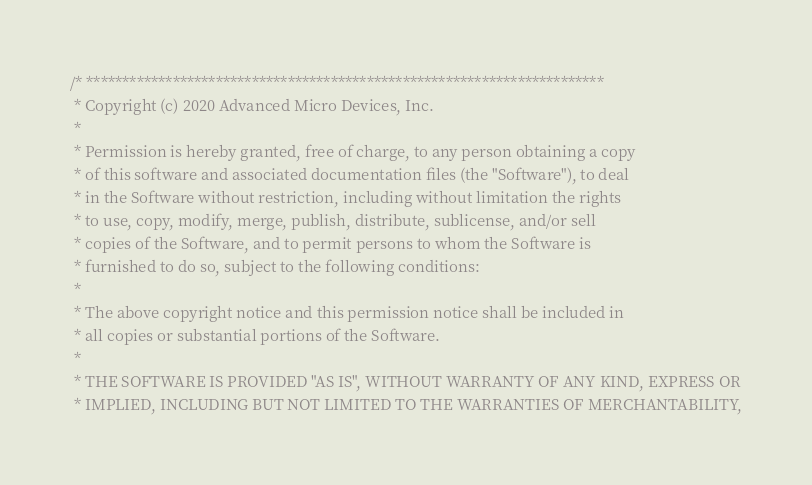<code> <loc_0><loc_0><loc_500><loc_500><_C++_>/* ************************************************************************
 * Copyright (c) 2020 Advanced Micro Devices, Inc.
 *
 * Permission is hereby granted, free of charge, to any person obtaining a copy
 * of this software and associated documentation files (the "Software"), to deal
 * in the Software without restriction, including without limitation the rights
 * to use, copy, modify, merge, publish, distribute, sublicense, and/or sell
 * copies of the Software, and to permit persons to whom the Software is
 * furnished to do so, subject to the following conditions:
 *
 * The above copyright notice and this permission notice shall be included in
 * all copies or substantial portions of the Software.
 *
 * THE SOFTWARE IS PROVIDED "AS IS", WITHOUT WARRANTY OF ANY KIND, EXPRESS OR
 * IMPLIED, INCLUDING BUT NOT LIMITED TO THE WARRANTIES OF MERCHANTABILITY,</code> 